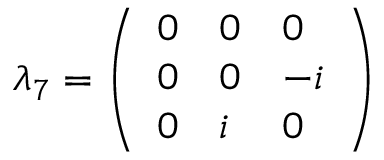Convert formula to latex. <formula><loc_0><loc_0><loc_500><loc_500>\lambda _ { 7 } = { \left ( \begin{array} { l l l } { 0 } & { 0 } & { 0 } \\ { 0 } & { 0 } & { - i } \\ { 0 } & { i } & { 0 } \end{array} \right ) }</formula> 